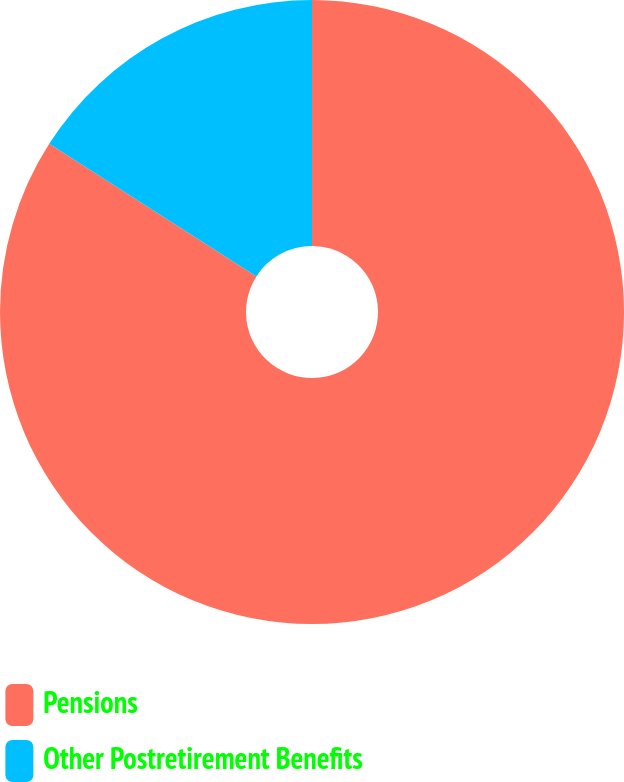Convert chart to OTSL. <chart><loc_0><loc_0><loc_500><loc_500><pie_chart><fcel>Pensions<fcel>Other Postretirement Benefits<nl><fcel>84.06%<fcel>15.94%<nl></chart> 